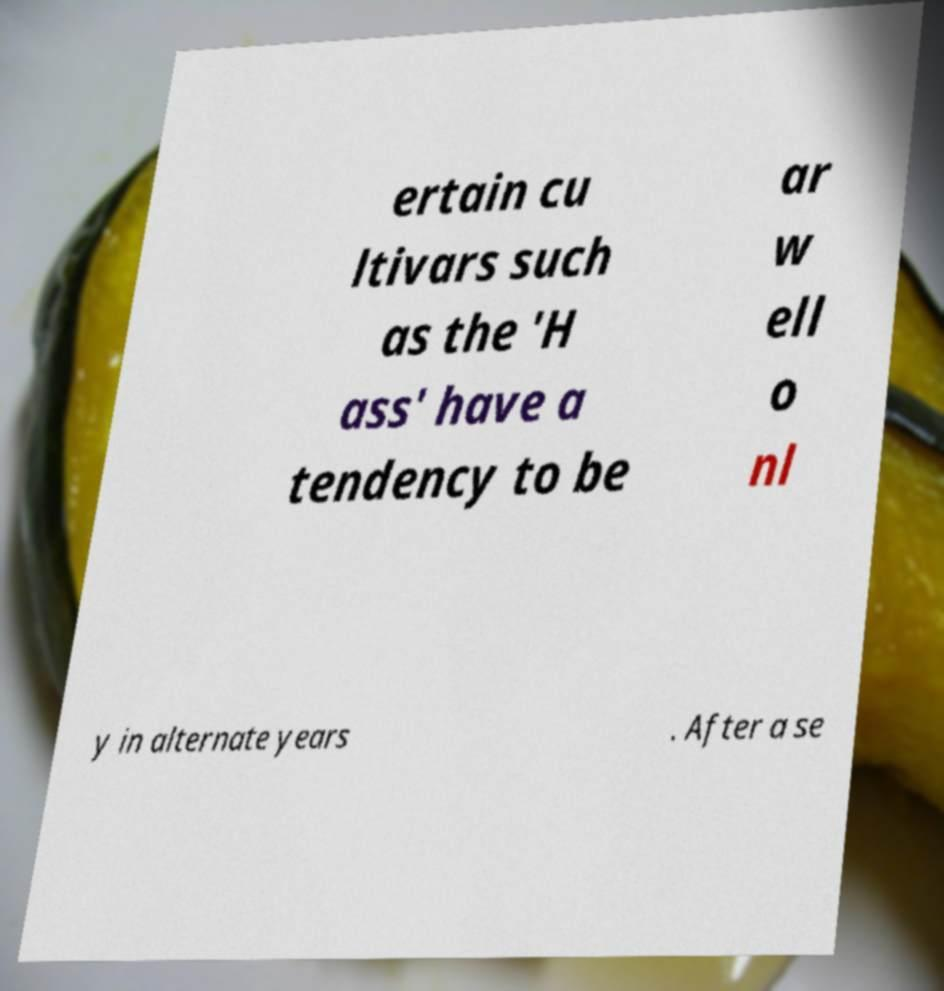Could you extract and type out the text from this image? ertain cu ltivars such as the 'H ass' have a tendency to be ar w ell o nl y in alternate years . After a se 